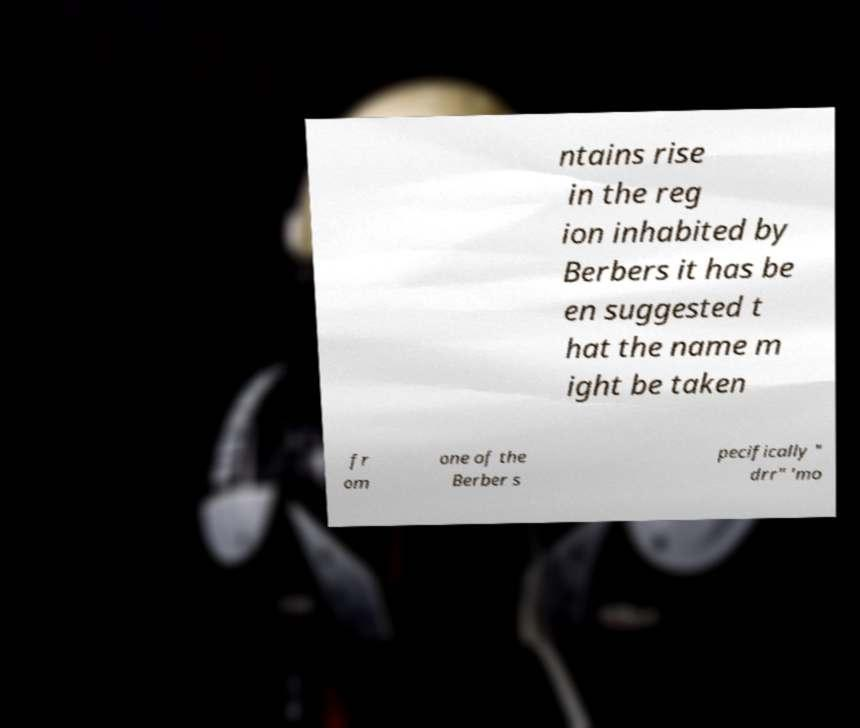Could you extract and type out the text from this image? ntains rise in the reg ion inhabited by Berbers it has be en suggested t hat the name m ight be taken fr om one of the Berber s pecifically " drr" 'mo 